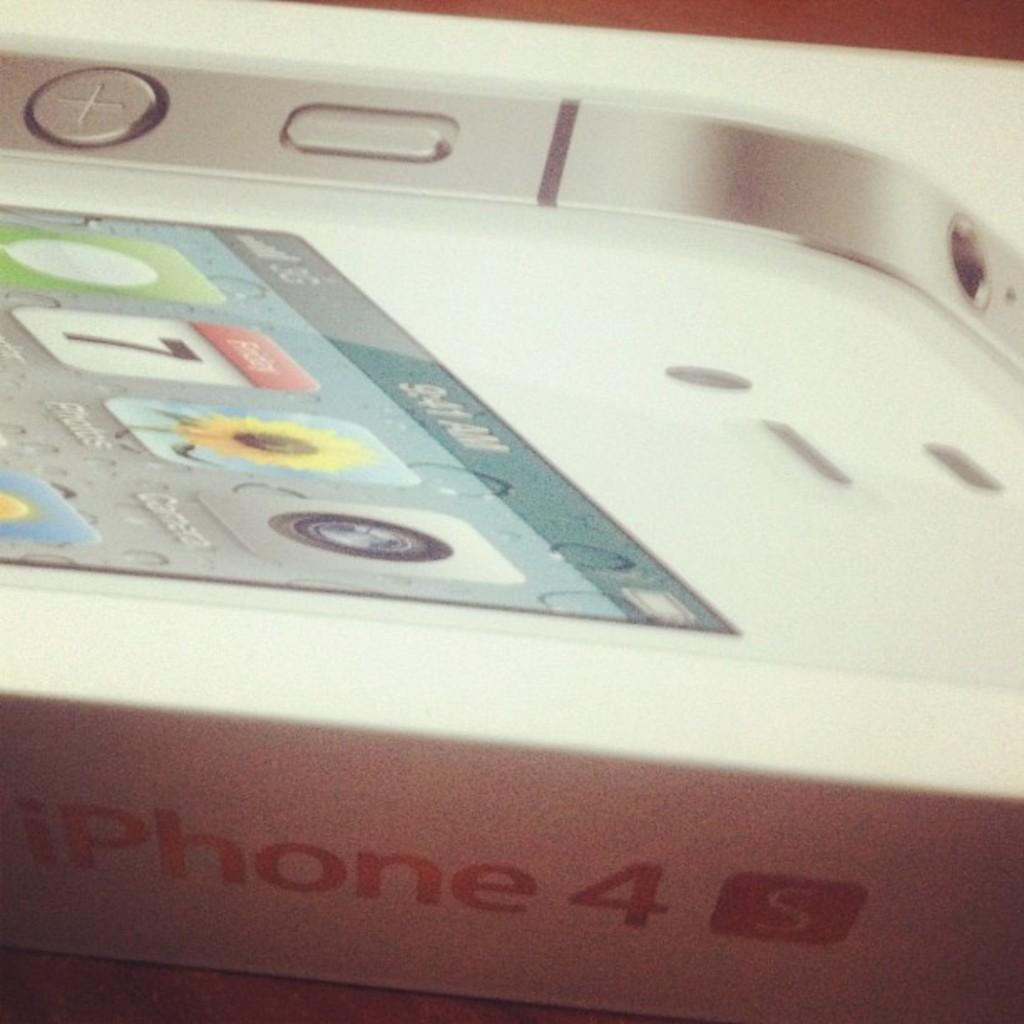<image>
Give a short and clear explanation of the subsequent image. close up what looks like white iphone 4s box 